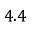Convert formula to latex. <formula><loc_0><loc_0><loc_500><loc_500>4 . 4</formula> 